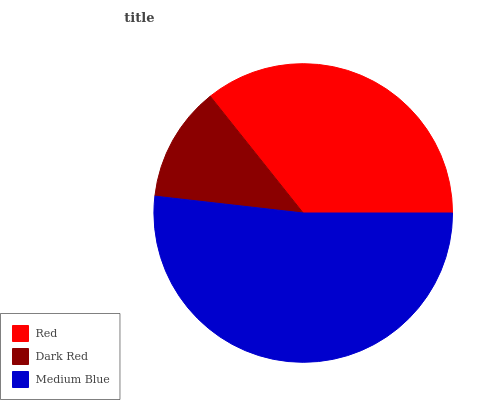Is Dark Red the minimum?
Answer yes or no. Yes. Is Medium Blue the maximum?
Answer yes or no. Yes. Is Medium Blue the minimum?
Answer yes or no. No. Is Dark Red the maximum?
Answer yes or no. No. Is Medium Blue greater than Dark Red?
Answer yes or no. Yes. Is Dark Red less than Medium Blue?
Answer yes or no. Yes. Is Dark Red greater than Medium Blue?
Answer yes or no. No. Is Medium Blue less than Dark Red?
Answer yes or no. No. Is Red the high median?
Answer yes or no. Yes. Is Red the low median?
Answer yes or no. Yes. Is Dark Red the high median?
Answer yes or no. No. Is Medium Blue the low median?
Answer yes or no. No. 